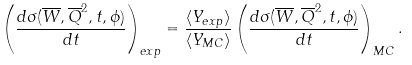<formula> <loc_0><loc_0><loc_500><loc_500>\left ( \frac { d \sigma ( \overline { W } , { \overline { Q } } ^ { 2 } , t , \phi ) } { d t } \right ) _ { e x p } = \frac { \langle Y _ { e x p } \rangle } { \langle Y _ { M C } \rangle } \left ( \frac { d \sigma ( \overline { W } , { \overline { Q } } ^ { 2 } , t , \phi ) } { d t } \right ) _ { M C } .</formula> 